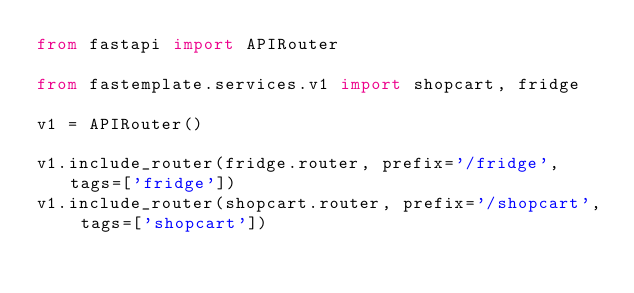<code> <loc_0><loc_0><loc_500><loc_500><_Python_>from fastapi import APIRouter

from fastemplate.services.v1 import shopcart, fridge

v1 = APIRouter()

v1.include_router(fridge.router, prefix='/fridge', tags=['fridge'])
v1.include_router(shopcart.router, prefix='/shopcart', tags=['shopcart'])
</code> 